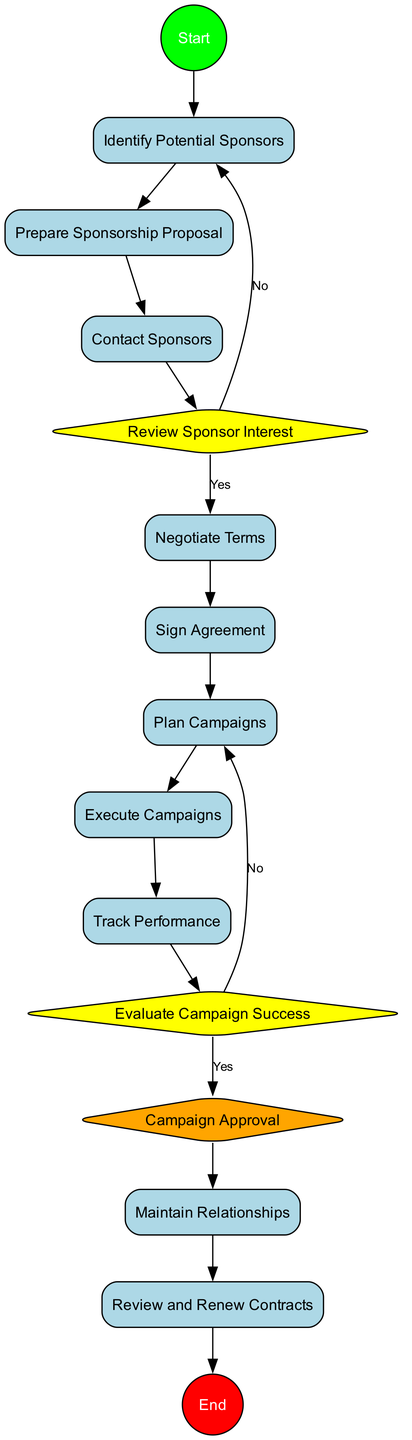What is the first activity in the diagram? The diagram starts with an initial node that leads to the first activity, which is to "Identify Potential Sponsors." This is clearly labeled as the first activity after the start node.
Answer: Identify Potential Sponsors How many decision nodes are there in the diagram? By reviewing the displayed nodes in the diagram, it's clear that there are two decision nodes: "Review Sponsor Interest" and "Evaluate Campaign Success." Counting these gives a total of two decision nodes.
Answer: 2 What comes after "Prepare Sponsorship Proposal"? Following "Prepare Sponsorship Proposal" in the flow of the diagram, the next activity is "Contact Sponsors." This is indicated by a direct edge connecting these two activities.
Answer: Contact Sponsors What happens if the sponsor is not interested in collaborating? If the sponsor is not interested, as indicated by the decision node "Review Sponsor Interest," the flow goes back to "Identify Potential Sponsors," indicating a loop for searching other potential sponsors.
Answer: Identify Potential Sponsors What is the final node labeled as in the diagram? The concluding element of the diagram is the end node, which has been explicitly labeled as "End." This indicates the termination of the activity process clearly.
Answer: End What is the purpose of the “Track Performance” activity? The “Track Performance” activity is aimed at monitoring and evaluating the effectiveness of the campaigns and sponsorship. This purpose is specified in the description associated with that activity.
Answer: Monitor effectiveness Which activity follows the decision node “Evaluate Campaign Success” if the results are successful? If the results are considered successful after evaluating the campaign, the flow moves to a merge node labeled "Campaign Approval," which combines the execution paths of the campaigns.
Answer: Campaign Approval How many activities are included in this diagram? By counting the listed activities from "Identify Potential Sponsors" to "Review and Renew Contracts," there are a total of nine distinct activities represented in the diagram.
Answer: 9 